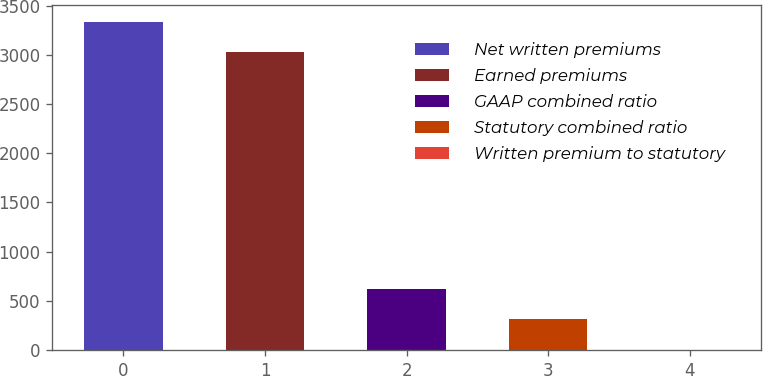Convert chart. <chart><loc_0><loc_0><loc_500><loc_500><bar_chart><fcel>Net written premiums<fcel>Earned premiums<fcel>GAAP combined ratio<fcel>Statutory combined ratio<fcel>Written premium to statutory<nl><fcel>3338.72<fcel>3029<fcel>620.24<fcel>310.52<fcel>0.8<nl></chart> 